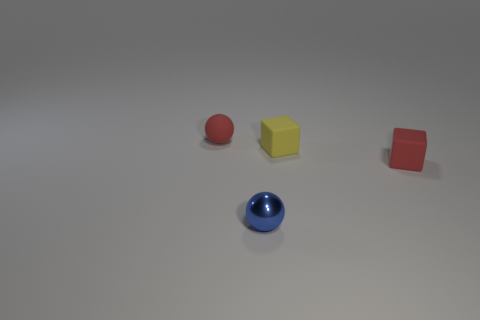What materials do the objects in this image seem to be made of? The objects displayed appear to consist of different materials. The red ball looks like it could be made of rubber, the yellow and red blocks seem to be plastic, and the blue ball has the distinct sheen of polished metal. 